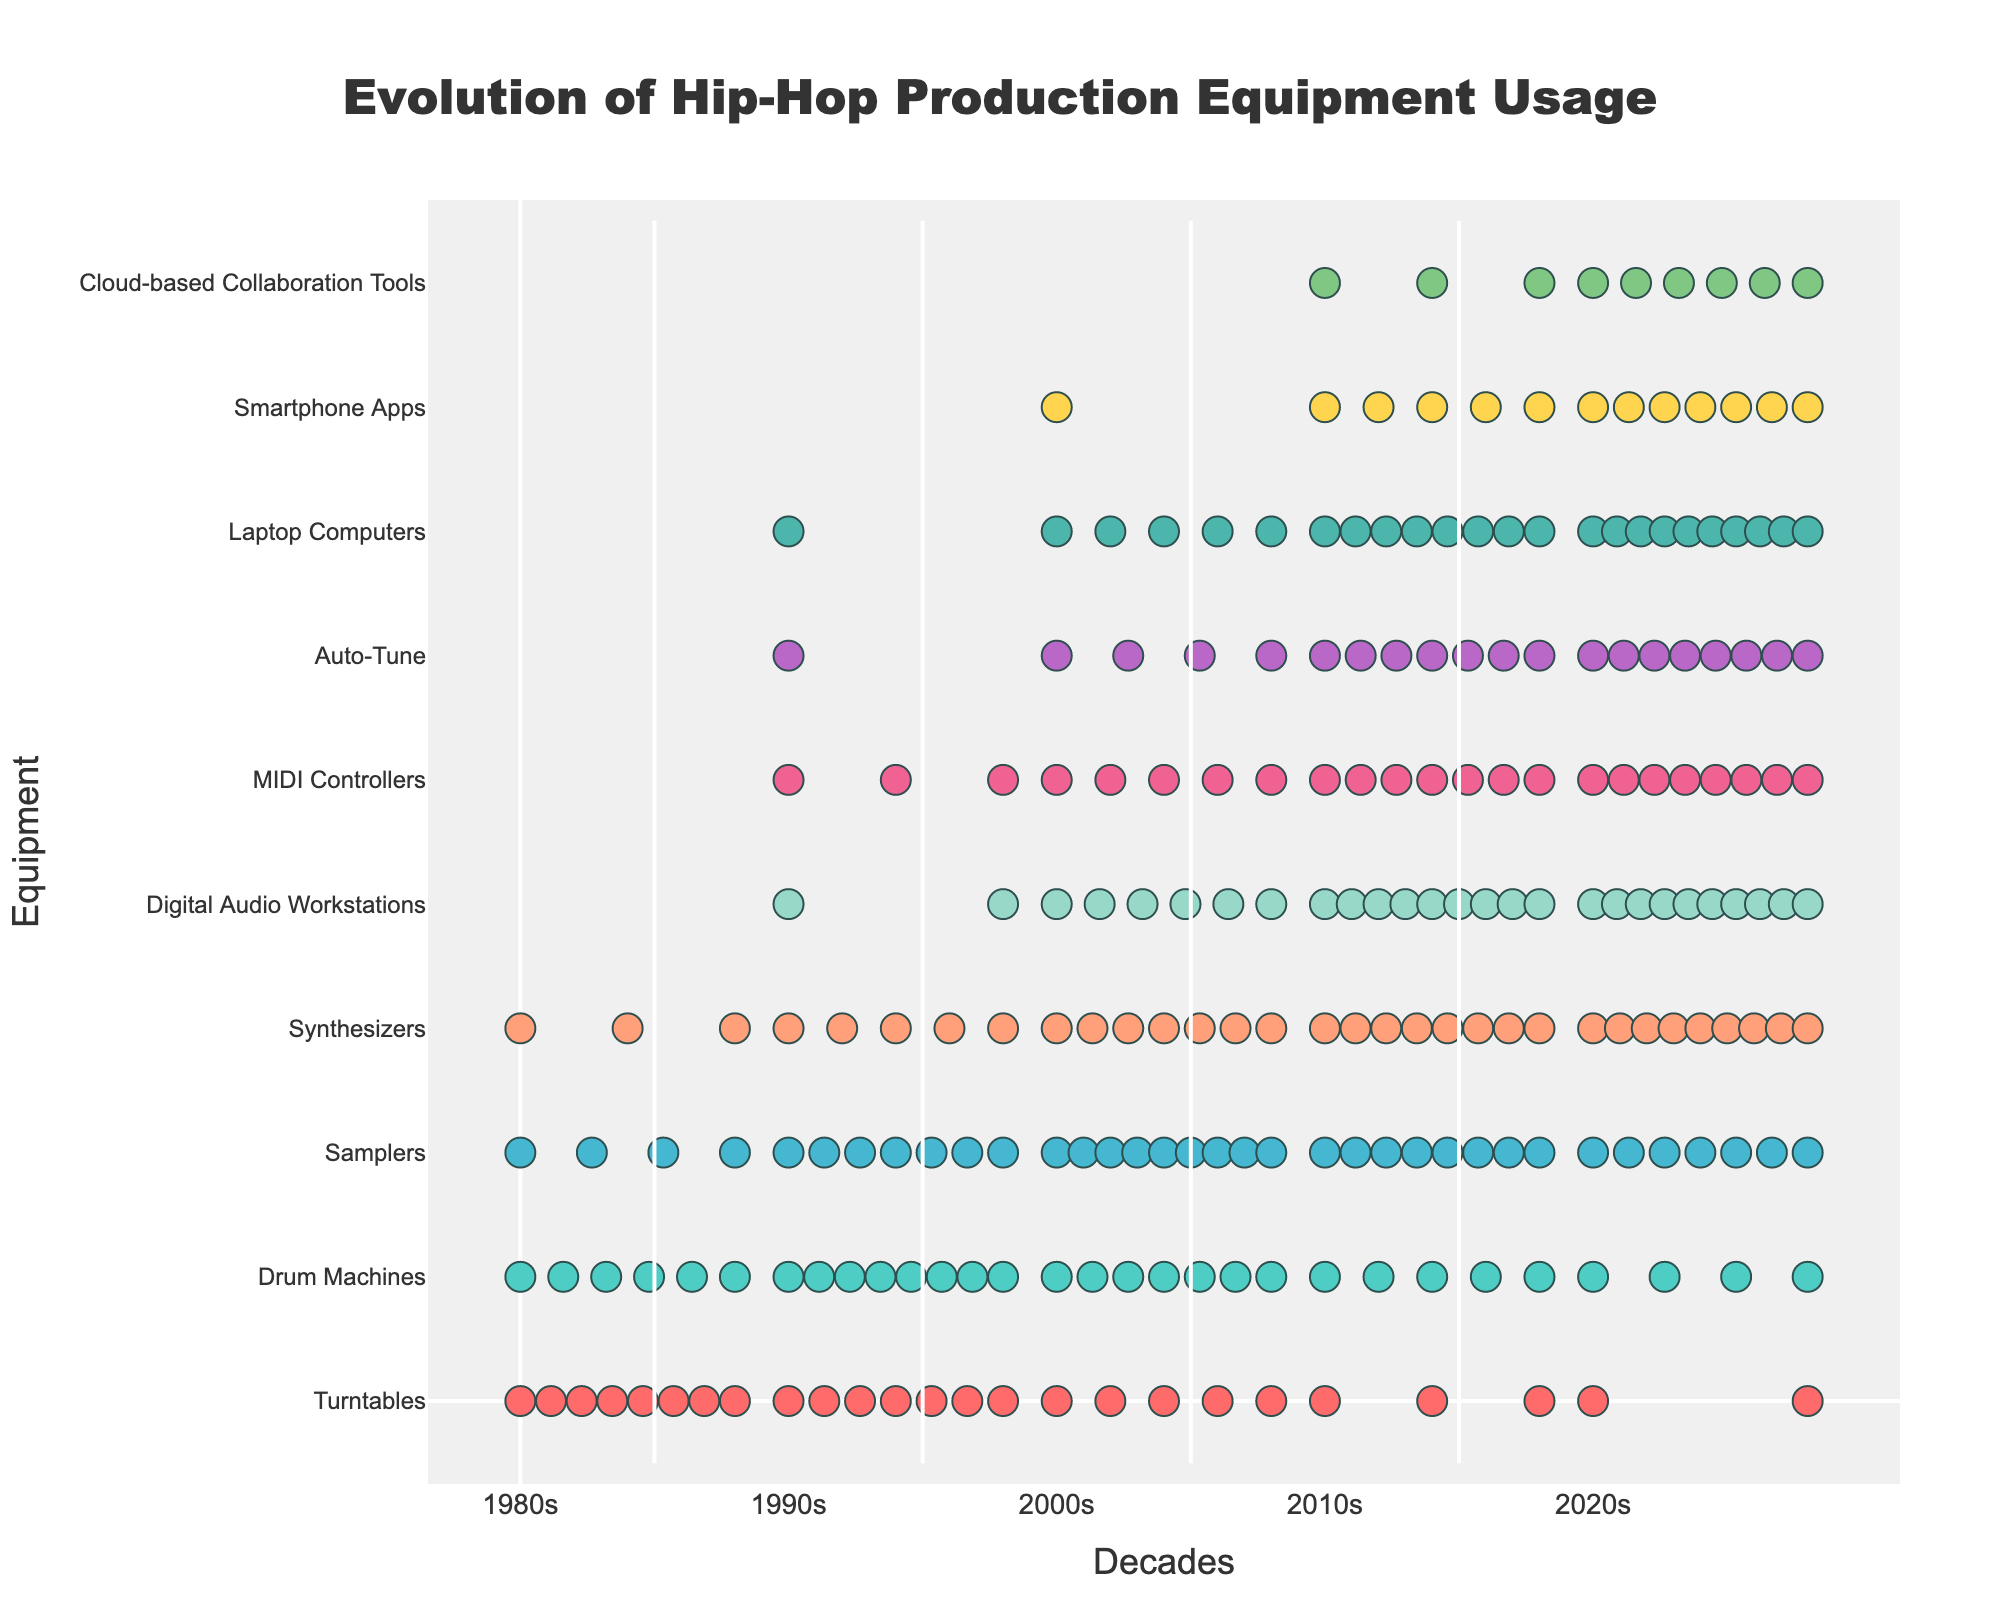What is the title of the figure? The title is usually found at the top of the figure. For this Isotype Plot, the title is clearly indicated at the top center.
Answer: Evolution of Hip-Hop Production Equipment Usage Which piece of equipment saw the largest increase in usage from the 1980s to the 2020s? Compare the usage counts for each equipment in the 1980s and the 2020s and determine which one has the largest difference.
Answer: Digital Audio Workstations How many pieces of equipment were used in the 1980s? By looking at the data points (icons) representing the usage in the 1980s for each piece of equipment, count the number of data points.
Answer: 21 What is the total usage count for synthesizers across all decades? Add up the usage counts for synthesizers in each decade: 3 + 5 + 7 + 8 + 9.
Answer: 32 Which equipment has the least usage in the 2020s? Compare the usage counts of all equipment in the 2020s and find the minimum value.
Answer: Turntables How did the usage of drum machines change from the 1990s to the 2000s? Subtract the usage count of drum machines in the 2000s from its usage count in the 1990s: 7 - 8.
Answer: Decreased by 1 What is the difference in the number of icons between MIDI Controllers and Auto-Tune in the 2010s? Subtract the number of icons for Auto-Tune from the number of icons for MIDI Controllers in the 2010s: 7 - 7.
Answer: 0 Which piece of equipment was not used at all in the 1980s? Identify the equipment that has a zero count in the 1980s.
Answer: Digital Audio Workstations, MIDI Controllers, Auto-Tune, Laptop Computers, Smartphone Apps, Cloud-based Collaboration Tools In which decade did samplers see their peak usage? Look at the usage counts for samplers across all decades and identify the highest value.
Answer: 2000s By how much did the usage of smartphone apps increase from the 2000s to the 2020s? Subtract the usage count in the 2000s from the usage count in the 2020s: 7 - 1.
Answer: Increased by 6 